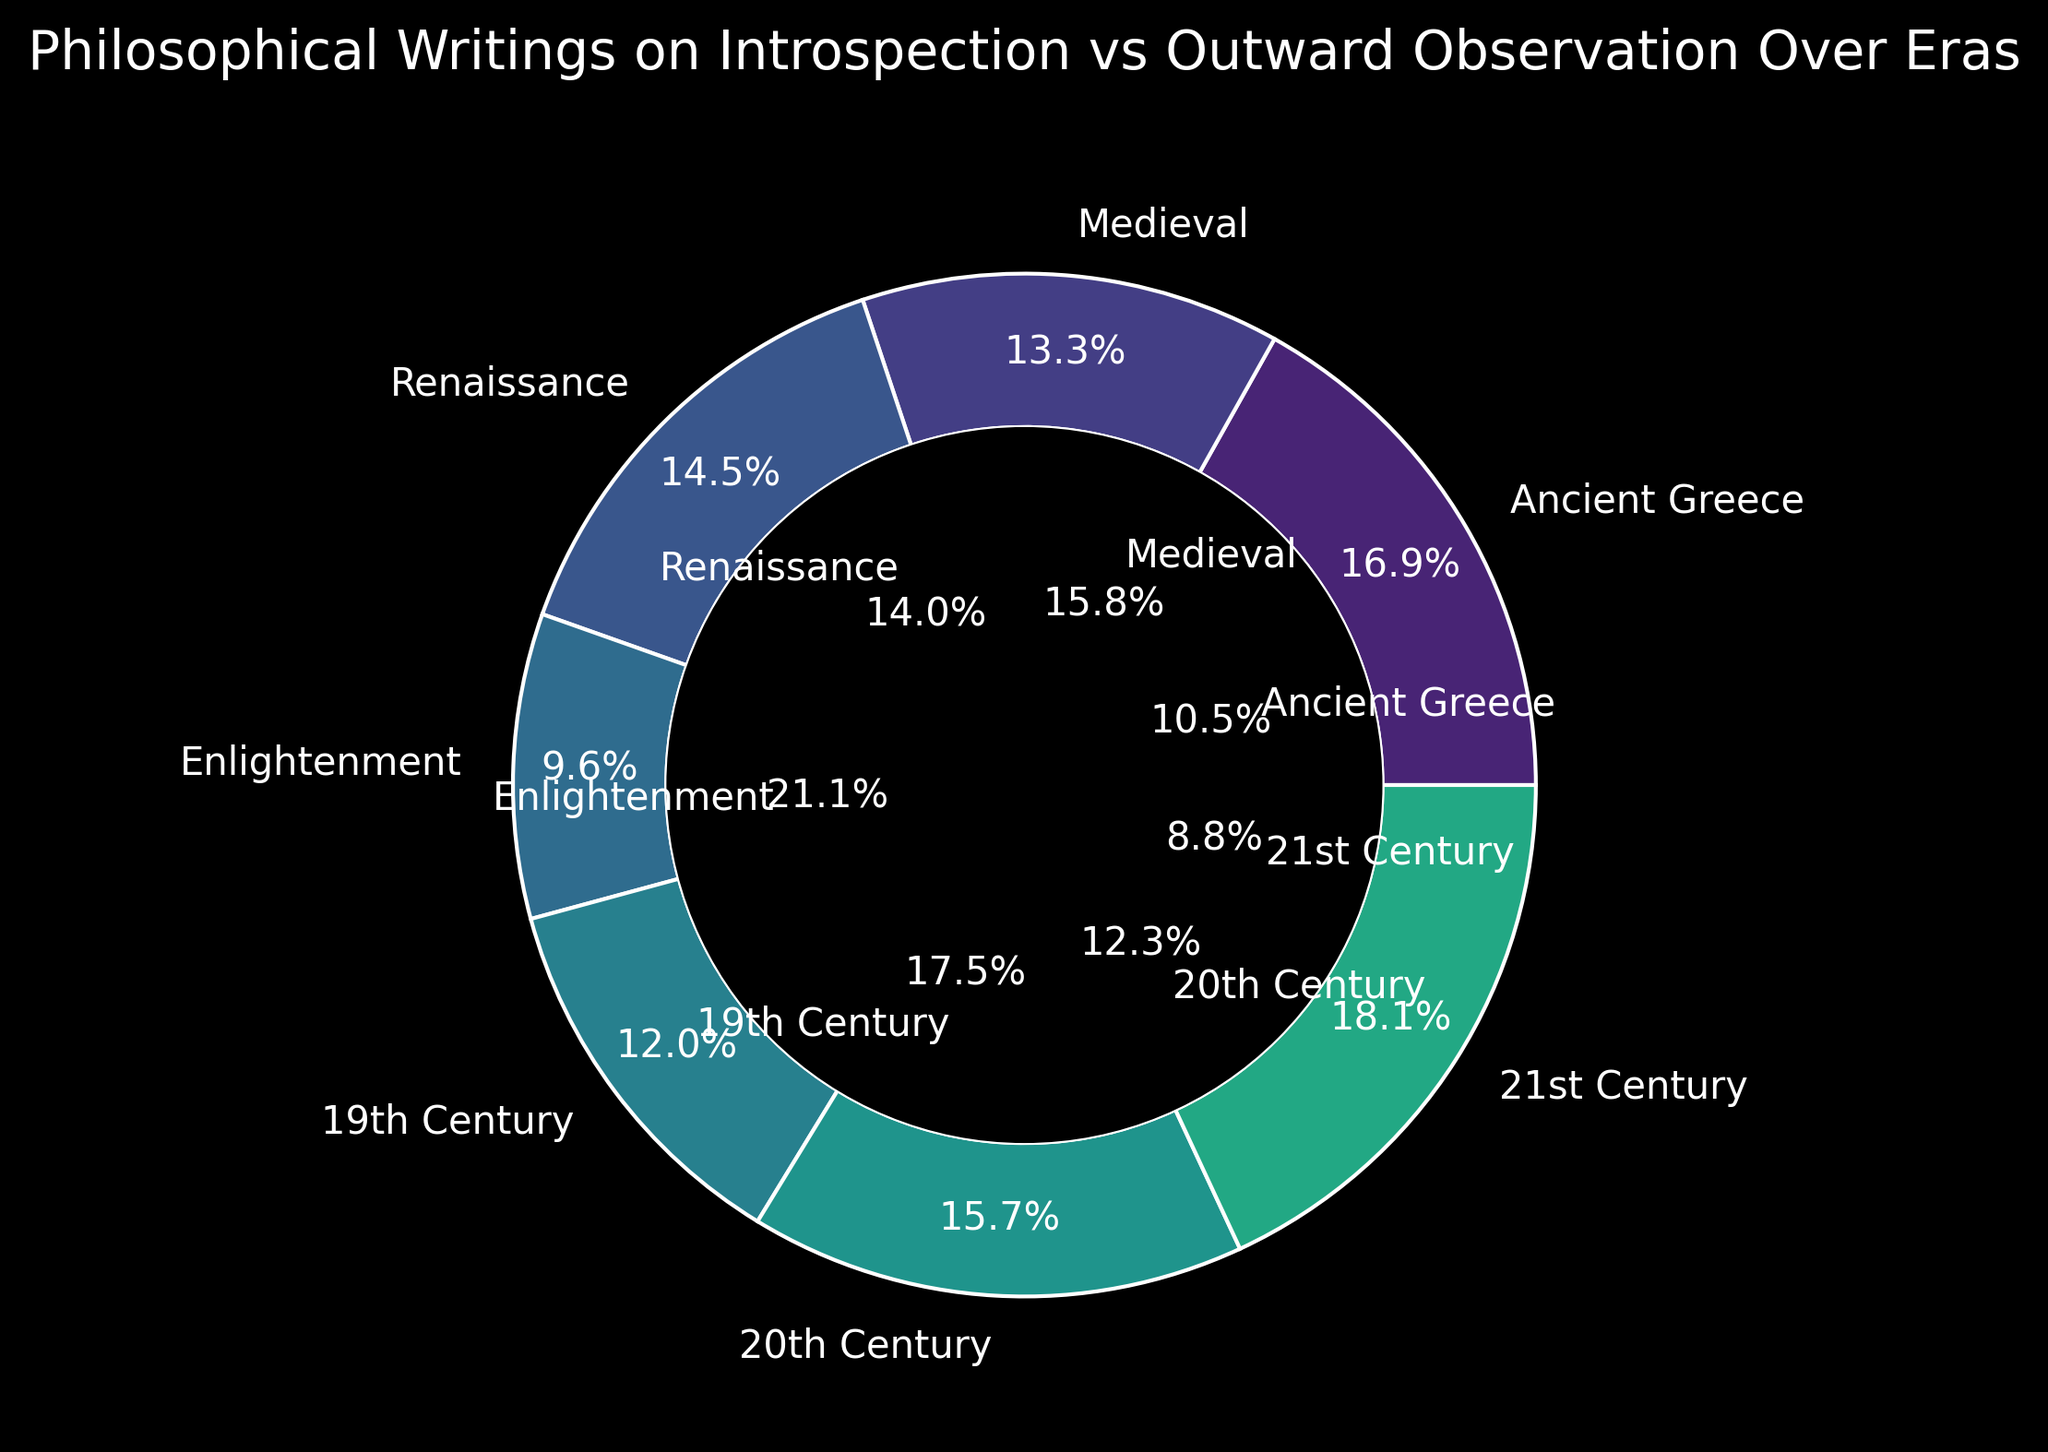What percentage of philosophical writings in the 21st Century focus on introspection? Look at the ring chart and find the segment labeled "21st Century". The outer segment, representing introspection, should show the percentage value.
Answer: 75% How does the focus on introspection versus outward observation in the Medieval era compare to the Renaissance? Compare the two segments labeled "Medieval" and "Renaissance" on both the inner and outer circles.
Answer: Medieval has 55% introspection and 45% outward observation; Renaissance has 60% introspection and 40% outward observation What is the era with the highest focus on outward observation? Look at the inner segments of all eras and identify the largest percentage.
Answer: Enlightenment Which era shows an equal focus on introspection and outward observation? Look for the era where both the inner and outer segments show the same values.
Answer: 19th Century What is the combined percentage of introspective writings in Ancient Greece and 20th Century? Add the percentages from the segments labeled "Ancient Greece" and "20th Century" in the outer circle representing introspection.
Answer: 70% + 65% = 135% How does the 20th Century compare to the Enlightenment in terms of introspective writings? Look at the introspection percentages of the 20th Century and Enlightenment segments in the outer circle and compare.
Answer: 20th Century focuses 65% on introspection, Enlightenment 40% What trend can you observe from Ancient Greece to the 21st Century regarding introspection? Visually trace the trend from one segment to the next in the outer circle from Ancient Greece to the 21st Century.
Answer: Generally increasing Which era has the lowest focus on introspection? Identify the era with the smallest percentage in the outer circle representing introspection.
Answer: Enlightenment What is the average focus on introspection across all eras? Add all the introspection percentages and divide by the number of eras. (70 + 55 + 60 + 40 + 50 + 65 + 75) / 7 = 59.3%
Answer: 59.3% Which two consecutive eras show the greatest decrease in the focus on introspection? Compare the differences between consecutive segments in the outer circle. Subtract the higher percentage from the lower percentage for each pair and find the maximum decrease.
Answer: Renaissance to Enlightenment (60% to 40%, a 20% decrease) 